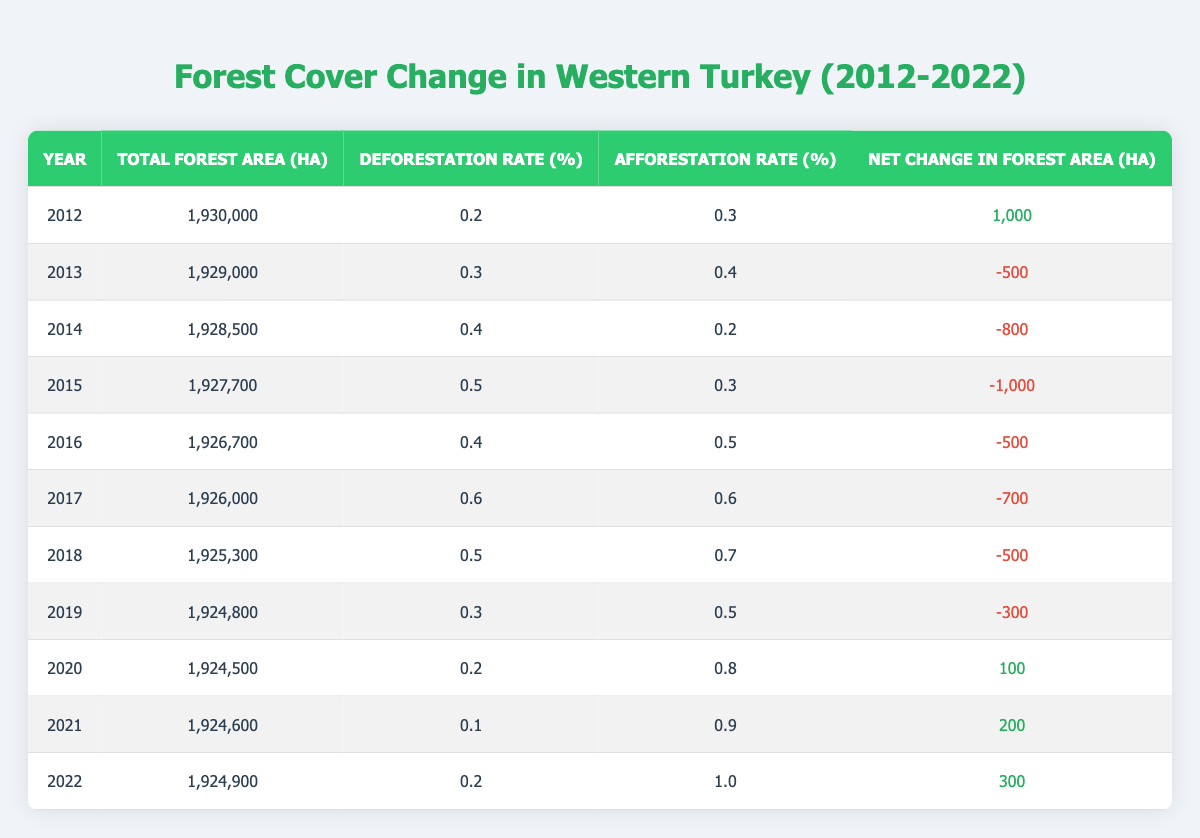What was the total forest area in Western Turkey in 2015? Referring to the table, the total forest area in 2015 is listed as 1,927,700 ha.
Answer: 1,927,700 ha In which year did the deforestation rate peak between 2012 and 2022? Looking through the deforestation rates in the table, the highest rate is 0.6% in 2017.
Answer: 2017 What is the average deforestation rate over the decade (2012-2022)? To find the average deforestation rate, sum all the rates: (0.2 + 0.3 + 0.4 + 0.5 + 0.4 + 0.6 + 0.5 + 0.3 + 0.2 + 0.1 + 0.2) = 3.7, then divide by 11 years, which gives approximately 0.336.
Answer: 0.336 Did the forest area increase from 2020 to 2021? Comparing the total forest area in 2020 (1,924,500 ha) and in 2021 (1,924,600 ha), the area indeed increased by 100 ha.
Answer: Yes What was the net change in forest area in 2019? In the table, the net change in forest area for 2019 is listed as -300 ha, indicating a decrease.
Answer: -300 ha Which year saw the highest afforestation rate and what was the rate? By examining the afforestation rates, the highest rate is found in 2022, which is 1.0%.
Answer: 1.0% How many hectares of forest area were lost in total from 2012 to 2019? The losses from each year (2013: -500, 2014: -800, 2015: -1000, 2016: -500, 2017: -700, 2018: -500, 2019: -300) sum to 3,300 ha.
Answer: 3,300 ha Was there a year where both the deforestation and afforestation rates were equal? In 2017, both the deforestation rate (0.6%) and afforestation rate (0.6%) were equal.
Answer: Yes What was the net change in forest area from 2021 to 2022? The net change for 2021 is 200 ha and for 2022 is 300 ha. Thus, the change from 2021 to 2022 is an increase of 100 ha (300 - 200).
Answer: 100 ha 